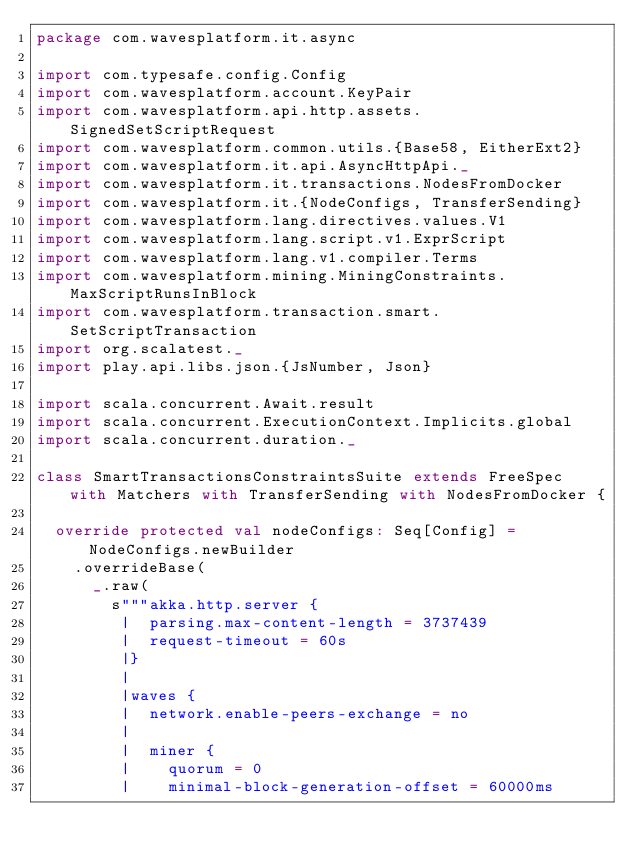<code> <loc_0><loc_0><loc_500><loc_500><_Scala_>package com.wavesplatform.it.async

import com.typesafe.config.Config
import com.wavesplatform.account.KeyPair
import com.wavesplatform.api.http.assets.SignedSetScriptRequest
import com.wavesplatform.common.utils.{Base58, EitherExt2}
import com.wavesplatform.it.api.AsyncHttpApi._
import com.wavesplatform.it.transactions.NodesFromDocker
import com.wavesplatform.it.{NodeConfigs, TransferSending}
import com.wavesplatform.lang.directives.values.V1
import com.wavesplatform.lang.script.v1.ExprScript
import com.wavesplatform.lang.v1.compiler.Terms
import com.wavesplatform.mining.MiningConstraints.MaxScriptRunsInBlock
import com.wavesplatform.transaction.smart.SetScriptTransaction
import org.scalatest._
import play.api.libs.json.{JsNumber, Json}

import scala.concurrent.Await.result
import scala.concurrent.ExecutionContext.Implicits.global
import scala.concurrent.duration._

class SmartTransactionsConstraintsSuite extends FreeSpec with Matchers with TransferSending with NodesFromDocker {

  override protected val nodeConfigs: Seq[Config] = NodeConfigs.newBuilder
    .overrideBase(
      _.raw(
        s"""akka.http.server {
         |  parsing.max-content-length = 3737439
         |  request-timeout = 60s
         |}
         |
         |waves {
         |  network.enable-peers-exchange = no
         |
         |  miner {
         |    quorum = 0
         |    minimal-block-generation-offset = 60000ms</code> 